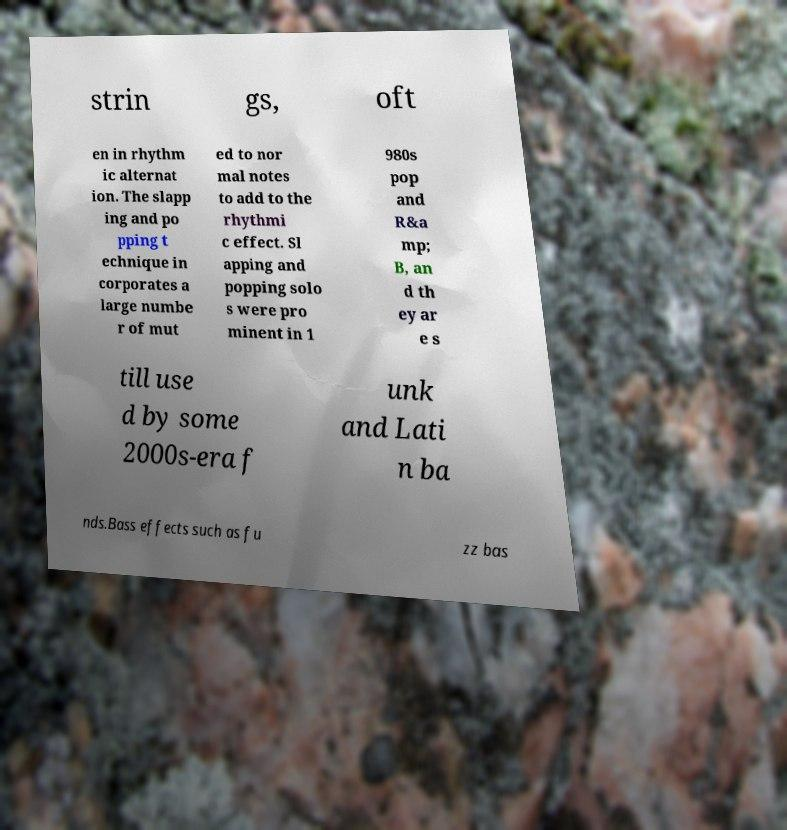Could you assist in decoding the text presented in this image and type it out clearly? strin gs, oft en in rhythm ic alternat ion. The slapp ing and po pping t echnique in corporates a large numbe r of mut ed to nor mal notes to add to the rhythmi c effect. Sl apping and popping solo s were pro minent in 1 980s pop and R&a mp; B, an d th ey ar e s till use d by some 2000s-era f unk and Lati n ba nds.Bass effects such as fu zz bas 